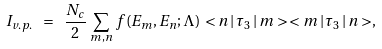<formula> <loc_0><loc_0><loc_500><loc_500>I _ { v . p . } \ = \ \frac { N _ { c } } { 2 } \, \sum _ { m , n } \, f ( E _ { m } , E _ { n } ; \Lambda ) \, < n \, | \, \tau _ { 3 } \, | \, m > \, < m \, | \, \tau _ { 3 } \, | \, n > ,</formula> 